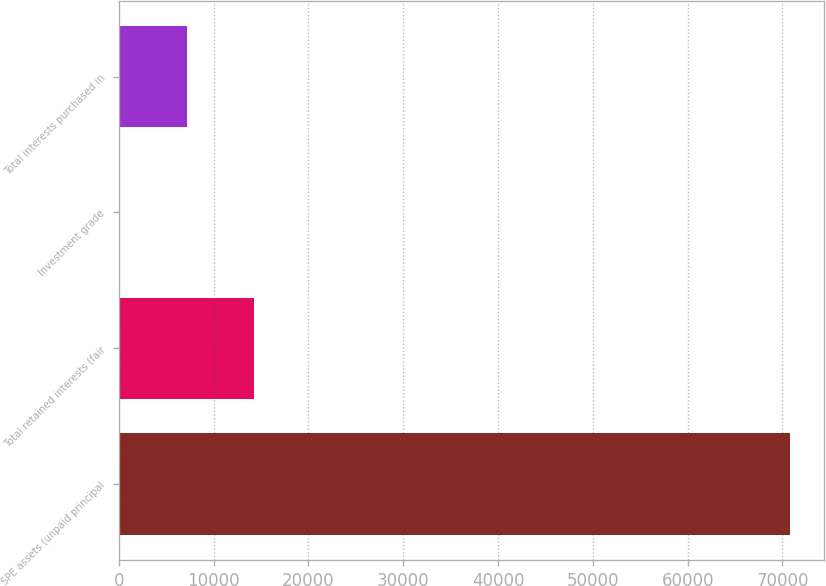Convert chart. <chart><loc_0><loc_0><loc_500><loc_500><bar_chart><fcel>SPE assets (unpaid principal<fcel>Total retained interests (fair<fcel>Investment grade<fcel>Total interests purchased in<nl><fcel>70824<fcel>14264<fcel>124<fcel>7194<nl></chart> 